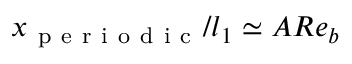Convert formula to latex. <formula><loc_0><loc_0><loc_500><loc_500>x _ { p e r i o d i c } / l _ { 1 } \simeq A R e _ { b }</formula> 